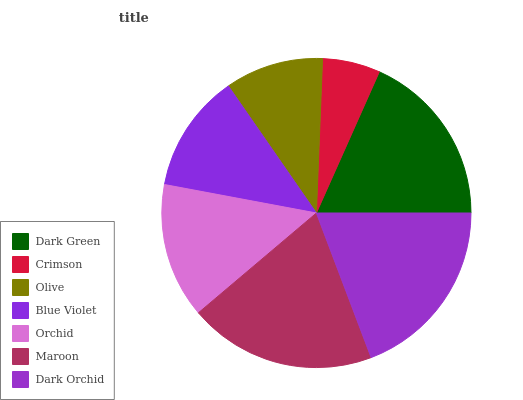Is Crimson the minimum?
Answer yes or no. Yes. Is Maroon the maximum?
Answer yes or no. Yes. Is Olive the minimum?
Answer yes or no. No. Is Olive the maximum?
Answer yes or no. No. Is Olive greater than Crimson?
Answer yes or no. Yes. Is Crimson less than Olive?
Answer yes or no. Yes. Is Crimson greater than Olive?
Answer yes or no. No. Is Olive less than Crimson?
Answer yes or no. No. Is Orchid the high median?
Answer yes or no. Yes. Is Orchid the low median?
Answer yes or no. Yes. Is Olive the high median?
Answer yes or no. No. Is Olive the low median?
Answer yes or no. No. 